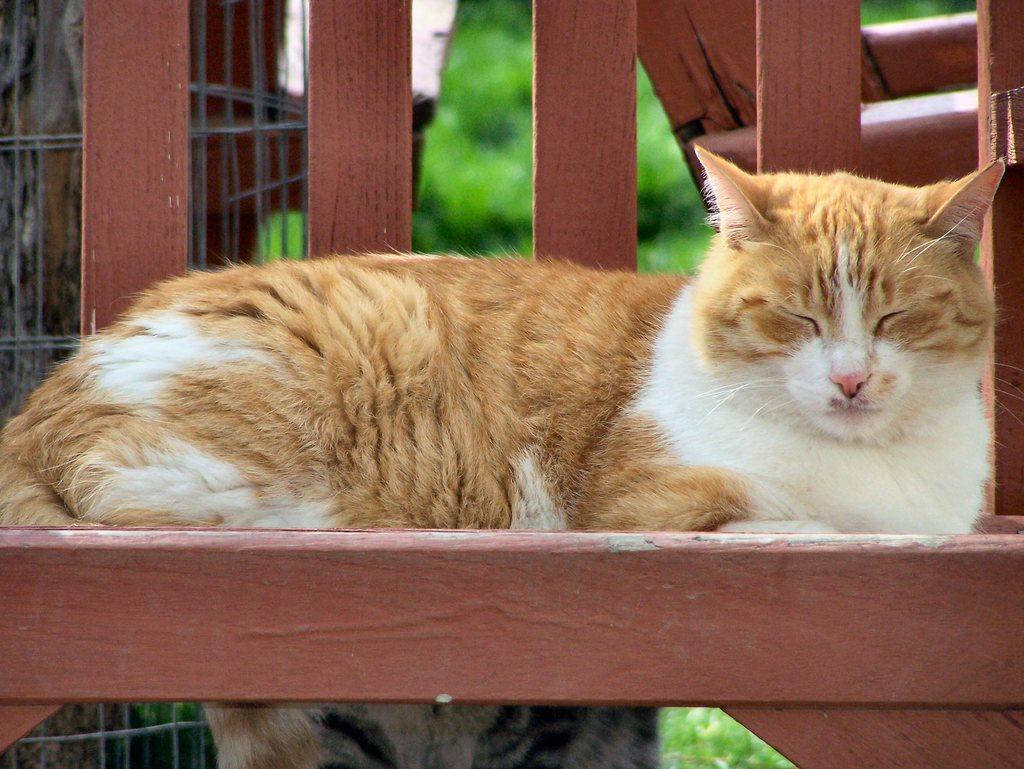Could you give a brief overview of what you see in this image? There is a cat on a wooden surface in the foreground area of the image, it seems like a tree, mesh and wooden planks in the background. 